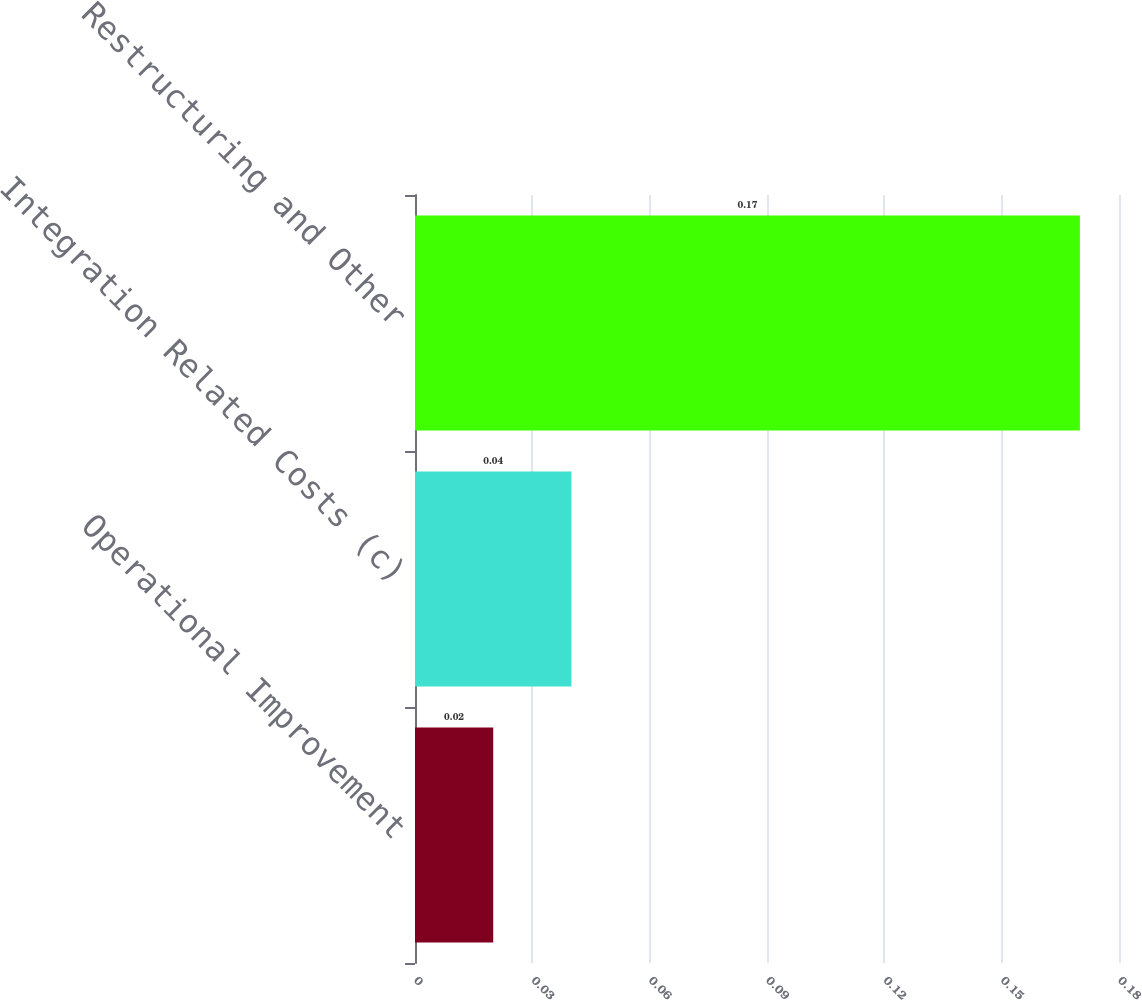Convert chart to OTSL. <chart><loc_0><loc_0><loc_500><loc_500><bar_chart><fcel>Operational Improvement<fcel>Integration Related Costs (c)<fcel>Restructuring and Other<nl><fcel>0.02<fcel>0.04<fcel>0.17<nl></chart> 